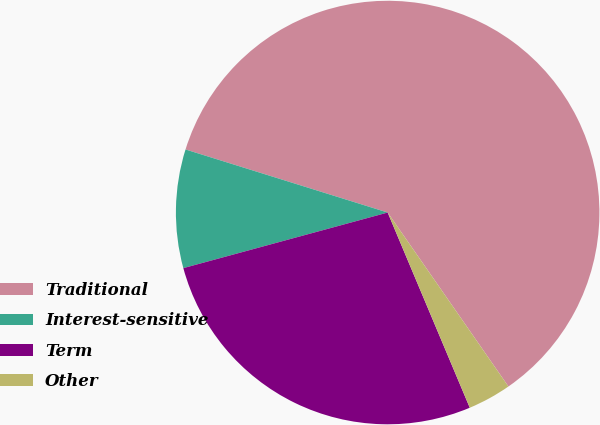<chart> <loc_0><loc_0><loc_500><loc_500><pie_chart><fcel>Traditional<fcel>Interest-sensitive<fcel>Term<fcel>Other<nl><fcel>60.53%<fcel>9.04%<fcel>27.11%<fcel>3.32%<nl></chart> 